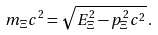<formula> <loc_0><loc_0><loc_500><loc_500>m _ { \Xi } c ^ { 2 } = \sqrt { E _ { \Xi } ^ { 2 } - p _ { \Xi } ^ { 2 } c ^ { 2 } } \, .</formula> 